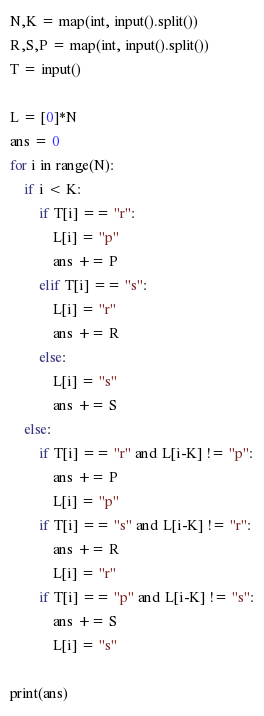Convert code to text. <code><loc_0><loc_0><loc_500><loc_500><_Python_>N,K = map(int, input().split())
R,S,P = map(int, input().split())
T = input()

L = [0]*N
ans = 0
for i in range(N):
    if i < K:
        if T[i] == "r":
            L[i] = "p"
            ans += P
        elif T[i] == "s":
            L[i] = "r"
            ans += R
        else:
            L[i] = "s"
            ans += S
    else:
        if T[i] == "r" and L[i-K] != "p":
            ans += P
            L[i] = "p"
        if T[i] == "s" and L[i-K] != "r":
            ans += R
            L[i] = "r"
        if T[i] == "p" and L[i-K] != "s":
            ans += S
            L[i] = "s"
                
print(ans)</code> 